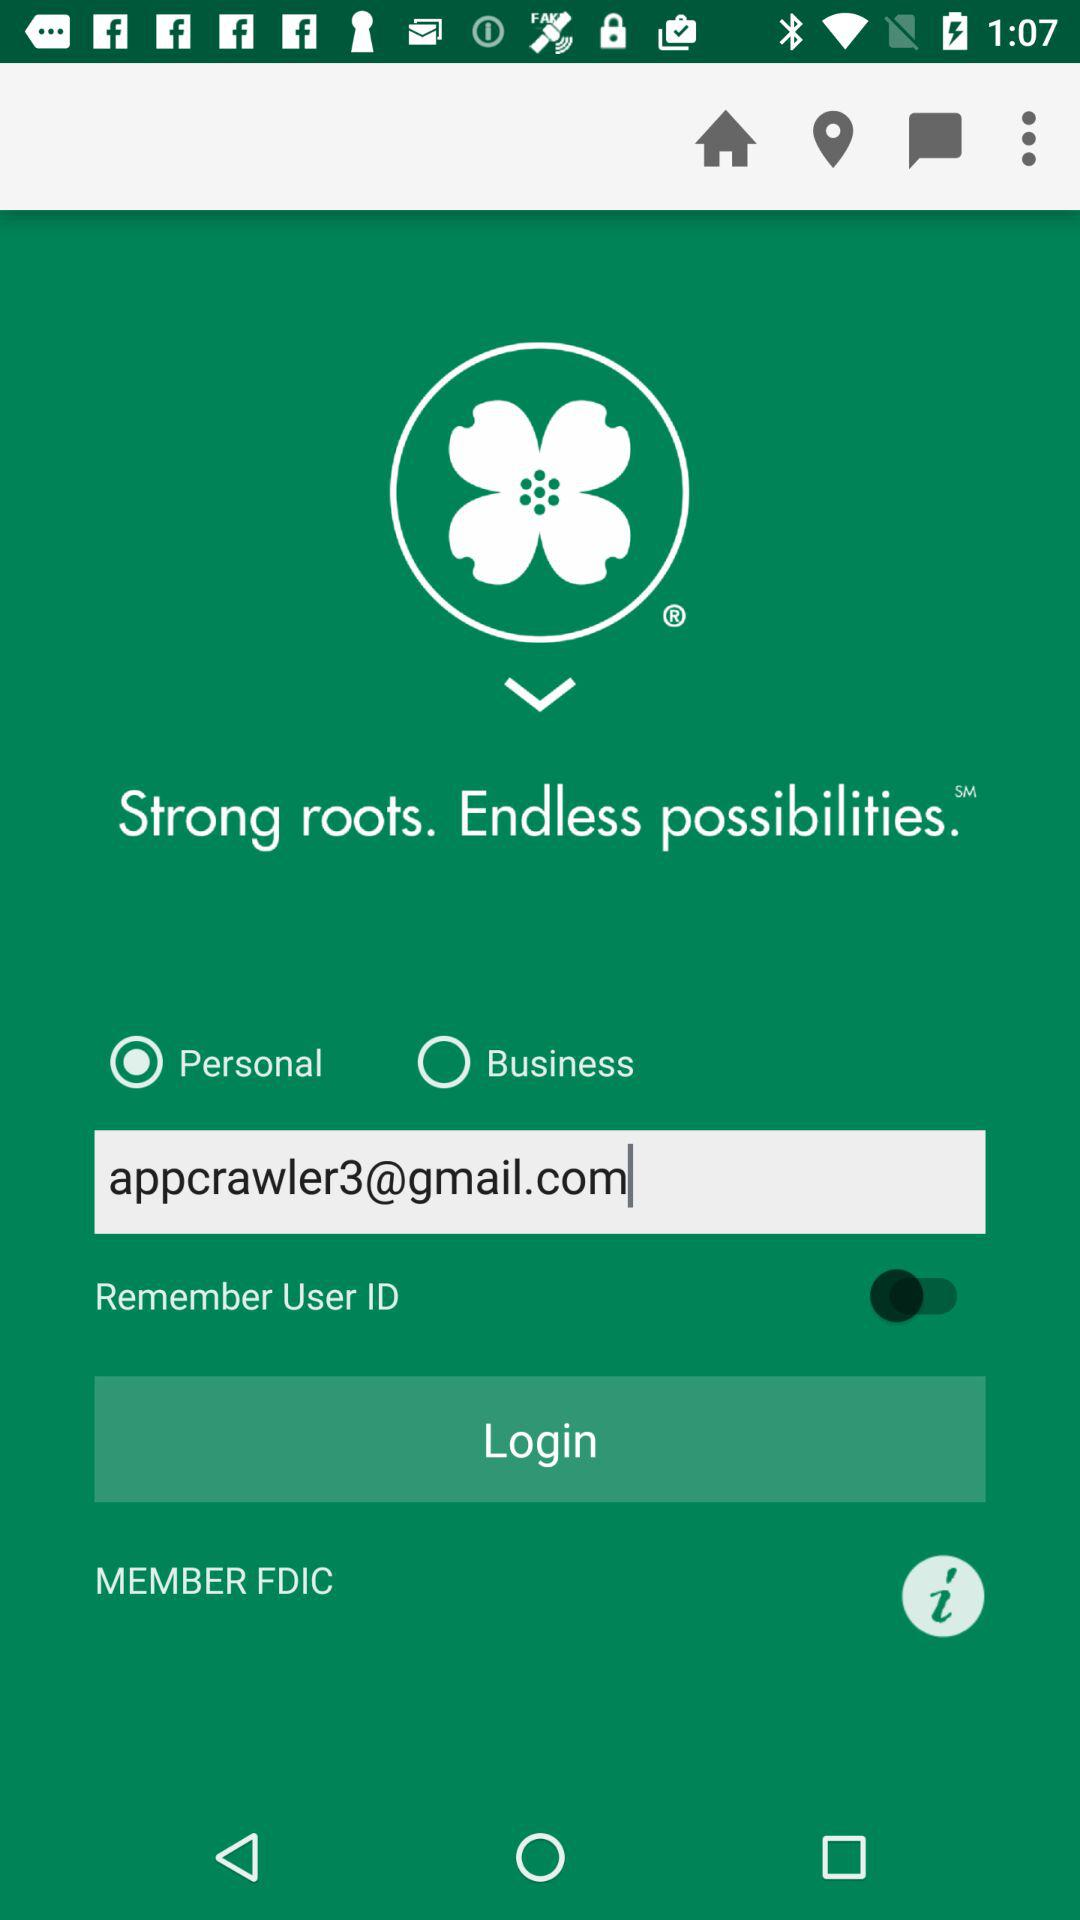What is the status of "Remember User ID"? The status of "Remember User ID" is "off". 